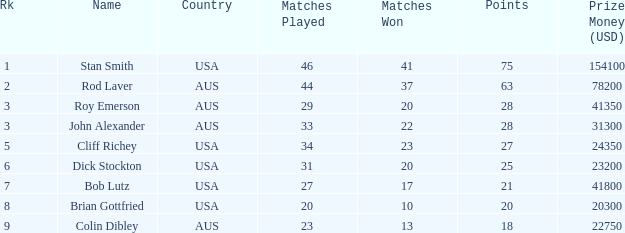Can you parse all the data within this table? {'header': ['Rk', 'Name', 'Country', 'Matches Played', 'Matches Won', 'Points', 'Prize Money (USD)'], 'rows': [['1', 'Stan Smith', 'USA', '46', '41', '75', '154100'], ['2', 'Rod Laver', 'AUS', '44', '37', '63', '78200'], ['3', 'Roy Emerson', 'AUS', '29', '20', '28', '41350'], ['3', 'John Alexander', 'AUS', '33', '22', '28', '31300'], ['5', 'Cliff Richey', 'USA', '34', '23', '27', '24350'], ['6', 'Dick Stockton', 'USA', '31', '20', '25', '23200'], ['7', 'Bob Lutz', 'USA', '27', '17', '21', '41800'], ['8', 'Brian Gottfried', 'USA', '20', '10', '20', '20300'], ['9', 'Colin Dibley', 'AUS', '23', '13', '18', '22750']]} How many countries had 21 points 1.0. 